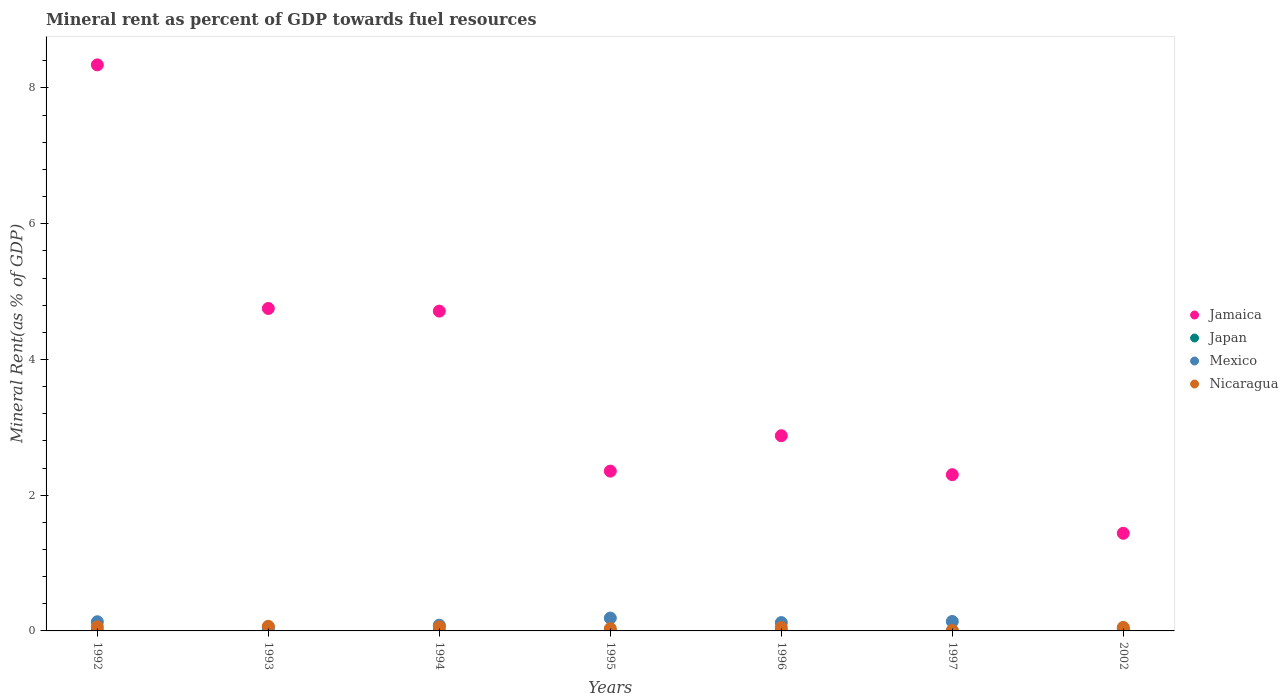How many different coloured dotlines are there?
Offer a very short reply. 4. Is the number of dotlines equal to the number of legend labels?
Ensure brevity in your answer.  Yes. What is the mineral rent in Jamaica in 1994?
Your response must be concise. 4.71. Across all years, what is the maximum mineral rent in Nicaragua?
Offer a terse response. 0.07. Across all years, what is the minimum mineral rent in Japan?
Provide a succinct answer. 4.86493891704915e-5. In which year was the mineral rent in Jamaica maximum?
Offer a very short reply. 1992. In which year was the mineral rent in Nicaragua minimum?
Your answer should be very brief. 1997. What is the total mineral rent in Nicaragua in the graph?
Your answer should be compact. 0.33. What is the difference between the mineral rent in Jamaica in 1995 and that in 1997?
Your answer should be very brief. 0.05. What is the difference between the mineral rent in Japan in 1993 and the mineral rent in Jamaica in 1992?
Offer a terse response. -8.34. What is the average mineral rent in Mexico per year?
Ensure brevity in your answer.  0.11. In the year 1992, what is the difference between the mineral rent in Nicaragua and mineral rent in Jamaica?
Your answer should be very brief. -8.28. In how many years, is the mineral rent in Mexico greater than 6.8 %?
Offer a terse response. 0. What is the ratio of the mineral rent in Mexico in 1995 to that in 1996?
Provide a succinct answer. 1.55. Is the mineral rent in Jamaica in 1992 less than that in 1993?
Make the answer very short. No. Is the difference between the mineral rent in Nicaragua in 1992 and 1997 greater than the difference between the mineral rent in Jamaica in 1992 and 1997?
Provide a succinct answer. No. What is the difference between the highest and the second highest mineral rent in Japan?
Give a very brief answer. 4.596113035733508e-5. What is the difference between the highest and the lowest mineral rent in Japan?
Keep it short and to the point. 0. Is it the case that in every year, the sum of the mineral rent in Japan and mineral rent in Mexico  is greater than the sum of mineral rent in Nicaragua and mineral rent in Jamaica?
Keep it short and to the point. No. Is it the case that in every year, the sum of the mineral rent in Mexico and mineral rent in Nicaragua  is greater than the mineral rent in Jamaica?
Offer a very short reply. No. How many years are there in the graph?
Your answer should be very brief. 7. What is the difference between two consecutive major ticks on the Y-axis?
Provide a short and direct response. 2. Where does the legend appear in the graph?
Offer a very short reply. Center right. How many legend labels are there?
Your response must be concise. 4. How are the legend labels stacked?
Offer a very short reply. Vertical. What is the title of the graph?
Your answer should be very brief. Mineral rent as percent of GDP towards fuel resources. Does "Bahamas" appear as one of the legend labels in the graph?
Provide a succinct answer. No. What is the label or title of the X-axis?
Your answer should be very brief. Years. What is the label or title of the Y-axis?
Keep it short and to the point. Mineral Rent(as % of GDP). What is the Mineral Rent(as % of GDP) in Jamaica in 1992?
Your answer should be very brief. 8.34. What is the Mineral Rent(as % of GDP) of Japan in 1992?
Your response must be concise. 0. What is the Mineral Rent(as % of GDP) of Mexico in 1992?
Offer a very short reply. 0.14. What is the Mineral Rent(as % of GDP) of Nicaragua in 1992?
Your response must be concise. 0.06. What is the Mineral Rent(as % of GDP) in Jamaica in 1993?
Make the answer very short. 4.75. What is the Mineral Rent(as % of GDP) of Japan in 1993?
Your answer should be very brief. 0. What is the Mineral Rent(as % of GDP) in Mexico in 1993?
Offer a terse response. 0.05. What is the Mineral Rent(as % of GDP) in Nicaragua in 1993?
Provide a short and direct response. 0.07. What is the Mineral Rent(as % of GDP) in Jamaica in 1994?
Ensure brevity in your answer.  4.71. What is the Mineral Rent(as % of GDP) in Japan in 1994?
Your answer should be compact. 0. What is the Mineral Rent(as % of GDP) in Mexico in 1994?
Your answer should be compact. 0.08. What is the Mineral Rent(as % of GDP) in Nicaragua in 1994?
Ensure brevity in your answer.  0.06. What is the Mineral Rent(as % of GDP) of Jamaica in 1995?
Give a very brief answer. 2.35. What is the Mineral Rent(as % of GDP) in Japan in 1995?
Provide a short and direct response. 0. What is the Mineral Rent(as % of GDP) of Mexico in 1995?
Offer a terse response. 0.19. What is the Mineral Rent(as % of GDP) of Nicaragua in 1995?
Provide a short and direct response. 0.03. What is the Mineral Rent(as % of GDP) of Jamaica in 1996?
Your response must be concise. 2.88. What is the Mineral Rent(as % of GDP) of Japan in 1996?
Your response must be concise. 0. What is the Mineral Rent(as % of GDP) in Mexico in 1996?
Ensure brevity in your answer.  0.12. What is the Mineral Rent(as % of GDP) in Nicaragua in 1996?
Provide a succinct answer. 0.05. What is the Mineral Rent(as % of GDP) in Jamaica in 1997?
Your response must be concise. 2.3. What is the Mineral Rent(as % of GDP) in Japan in 1997?
Provide a short and direct response. 4.86493891704915e-5. What is the Mineral Rent(as % of GDP) in Mexico in 1997?
Your answer should be compact. 0.14. What is the Mineral Rent(as % of GDP) of Nicaragua in 1997?
Provide a short and direct response. 0.01. What is the Mineral Rent(as % of GDP) of Jamaica in 2002?
Provide a short and direct response. 1.44. What is the Mineral Rent(as % of GDP) of Japan in 2002?
Ensure brevity in your answer.  0. What is the Mineral Rent(as % of GDP) in Mexico in 2002?
Give a very brief answer. 0.03. What is the Mineral Rent(as % of GDP) in Nicaragua in 2002?
Offer a terse response. 0.05. Across all years, what is the maximum Mineral Rent(as % of GDP) in Jamaica?
Offer a terse response. 8.34. Across all years, what is the maximum Mineral Rent(as % of GDP) of Japan?
Provide a short and direct response. 0. Across all years, what is the maximum Mineral Rent(as % of GDP) in Mexico?
Keep it short and to the point. 0.19. Across all years, what is the maximum Mineral Rent(as % of GDP) in Nicaragua?
Your answer should be very brief. 0.07. Across all years, what is the minimum Mineral Rent(as % of GDP) in Jamaica?
Offer a terse response. 1.44. Across all years, what is the minimum Mineral Rent(as % of GDP) in Japan?
Your response must be concise. 4.86493891704915e-5. Across all years, what is the minimum Mineral Rent(as % of GDP) of Mexico?
Make the answer very short. 0.03. Across all years, what is the minimum Mineral Rent(as % of GDP) in Nicaragua?
Your answer should be very brief. 0.01. What is the total Mineral Rent(as % of GDP) of Jamaica in the graph?
Make the answer very short. 26.77. What is the total Mineral Rent(as % of GDP) of Japan in the graph?
Make the answer very short. 0. What is the total Mineral Rent(as % of GDP) in Mexico in the graph?
Provide a succinct answer. 0.76. What is the total Mineral Rent(as % of GDP) in Nicaragua in the graph?
Your response must be concise. 0.33. What is the difference between the Mineral Rent(as % of GDP) of Jamaica in 1992 and that in 1993?
Your response must be concise. 3.59. What is the difference between the Mineral Rent(as % of GDP) of Japan in 1992 and that in 1993?
Give a very brief answer. 0. What is the difference between the Mineral Rent(as % of GDP) in Mexico in 1992 and that in 1993?
Your answer should be compact. 0.08. What is the difference between the Mineral Rent(as % of GDP) of Nicaragua in 1992 and that in 1993?
Provide a short and direct response. -0.01. What is the difference between the Mineral Rent(as % of GDP) in Jamaica in 1992 and that in 1994?
Ensure brevity in your answer.  3.63. What is the difference between the Mineral Rent(as % of GDP) of Japan in 1992 and that in 1994?
Your answer should be very brief. -0. What is the difference between the Mineral Rent(as % of GDP) in Mexico in 1992 and that in 1994?
Keep it short and to the point. 0.05. What is the difference between the Mineral Rent(as % of GDP) of Nicaragua in 1992 and that in 1994?
Keep it short and to the point. 0. What is the difference between the Mineral Rent(as % of GDP) of Jamaica in 1992 and that in 1995?
Ensure brevity in your answer.  5.99. What is the difference between the Mineral Rent(as % of GDP) in Mexico in 1992 and that in 1995?
Provide a short and direct response. -0.05. What is the difference between the Mineral Rent(as % of GDP) in Nicaragua in 1992 and that in 1995?
Provide a short and direct response. 0.03. What is the difference between the Mineral Rent(as % of GDP) in Jamaica in 1992 and that in 1996?
Give a very brief answer. 5.46. What is the difference between the Mineral Rent(as % of GDP) of Mexico in 1992 and that in 1996?
Keep it short and to the point. 0.01. What is the difference between the Mineral Rent(as % of GDP) of Nicaragua in 1992 and that in 1996?
Offer a terse response. 0.01. What is the difference between the Mineral Rent(as % of GDP) in Jamaica in 1992 and that in 1997?
Offer a terse response. 6.04. What is the difference between the Mineral Rent(as % of GDP) in Mexico in 1992 and that in 1997?
Keep it short and to the point. -0. What is the difference between the Mineral Rent(as % of GDP) of Nicaragua in 1992 and that in 1997?
Give a very brief answer. 0.05. What is the difference between the Mineral Rent(as % of GDP) of Jamaica in 1992 and that in 2002?
Your response must be concise. 6.9. What is the difference between the Mineral Rent(as % of GDP) in Japan in 1992 and that in 2002?
Ensure brevity in your answer.  0. What is the difference between the Mineral Rent(as % of GDP) of Mexico in 1992 and that in 2002?
Your answer should be very brief. 0.1. What is the difference between the Mineral Rent(as % of GDP) of Nicaragua in 1992 and that in 2002?
Keep it short and to the point. 0.01. What is the difference between the Mineral Rent(as % of GDP) in Jamaica in 1993 and that in 1994?
Your response must be concise. 0.04. What is the difference between the Mineral Rent(as % of GDP) of Japan in 1993 and that in 1994?
Make the answer very short. -0. What is the difference between the Mineral Rent(as % of GDP) in Mexico in 1993 and that in 1994?
Your response must be concise. -0.03. What is the difference between the Mineral Rent(as % of GDP) of Nicaragua in 1993 and that in 1994?
Your answer should be compact. 0.01. What is the difference between the Mineral Rent(as % of GDP) in Jamaica in 1993 and that in 1995?
Provide a short and direct response. 2.4. What is the difference between the Mineral Rent(as % of GDP) of Mexico in 1993 and that in 1995?
Your answer should be compact. -0.14. What is the difference between the Mineral Rent(as % of GDP) in Nicaragua in 1993 and that in 1995?
Provide a succinct answer. 0.03. What is the difference between the Mineral Rent(as % of GDP) of Jamaica in 1993 and that in 1996?
Offer a terse response. 1.88. What is the difference between the Mineral Rent(as % of GDP) in Japan in 1993 and that in 1996?
Make the answer very short. 0. What is the difference between the Mineral Rent(as % of GDP) of Mexico in 1993 and that in 1996?
Keep it short and to the point. -0.07. What is the difference between the Mineral Rent(as % of GDP) in Nicaragua in 1993 and that in 1996?
Offer a terse response. 0.02. What is the difference between the Mineral Rent(as % of GDP) in Jamaica in 1993 and that in 1997?
Your response must be concise. 2.45. What is the difference between the Mineral Rent(as % of GDP) in Japan in 1993 and that in 1997?
Your response must be concise. 0. What is the difference between the Mineral Rent(as % of GDP) in Mexico in 1993 and that in 1997?
Provide a succinct answer. -0.08. What is the difference between the Mineral Rent(as % of GDP) of Nicaragua in 1993 and that in 1997?
Your response must be concise. 0.06. What is the difference between the Mineral Rent(as % of GDP) in Jamaica in 1993 and that in 2002?
Offer a very short reply. 3.31. What is the difference between the Mineral Rent(as % of GDP) of Mexico in 1993 and that in 2002?
Offer a very short reply. 0.02. What is the difference between the Mineral Rent(as % of GDP) of Nicaragua in 1993 and that in 2002?
Provide a short and direct response. 0.02. What is the difference between the Mineral Rent(as % of GDP) in Jamaica in 1994 and that in 1995?
Provide a succinct answer. 2.36. What is the difference between the Mineral Rent(as % of GDP) of Japan in 1994 and that in 1995?
Your response must be concise. 0. What is the difference between the Mineral Rent(as % of GDP) in Mexico in 1994 and that in 1995?
Make the answer very short. -0.11. What is the difference between the Mineral Rent(as % of GDP) of Nicaragua in 1994 and that in 1995?
Give a very brief answer. 0.02. What is the difference between the Mineral Rent(as % of GDP) in Jamaica in 1994 and that in 1996?
Provide a succinct answer. 1.84. What is the difference between the Mineral Rent(as % of GDP) in Japan in 1994 and that in 1996?
Make the answer very short. 0. What is the difference between the Mineral Rent(as % of GDP) of Mexico in 1994 and that in 1996?
Your answer should be compact. -0.04. What is the difference between the Mineral Rent(as % of GDP) in Nicaragua in 1994 and that in 1996?
Provide a succinct answer. 0.01. What is the difference between the Mineral Rent(as % of GDP) of Jamaica in 1994 and that in 1997?
Keep it short and to the point. 2.41. What is the difference between the Mineral Rent(as % of GDP) of Mexico in 1994 and that in 1997?
Provide a succinct answer. -0.06. What is the difference between the Mineral Rent(as % of GDP) in Nicaragua in 1994 and that in 1997?
Provide a short and direct response. 0.05. What is the difference between the Mineral Rent(as % of GDP) of Jamaica in 1994 and that in 2002?
Make the answer very short. 3.27. What is the difference between the Mineral Rent(as % of GDP) in Japan in 1994 and that in 2002?
Offer a terse response. 0. What is the difference between the Mineral Rent(as % of GDP) of Mexico in 1994 and that in 2002?
Provide a succinct answer. 0.05. What is the difference between the Mineral Rent(as % of GDP) in Nicaragua in 1994 and that in 2002?
Provide a short and direct response. 0.01. What is the difference between the Mineral Rent(as % of GDP) of Jamaica in 1995 and that in 1996?
Offer a terse response. -0.52. What is the difference between the Mineral Rent(as % of GDP) in Japan in 1995 and that in 1996?
Make the answer very short. -0. What is the difference between the Mineral Rent(as % of GDP) of Mexico in 1995 and that in 1996?
Give a very brief answer. 0.07. What is the difference between the Mineral Rent(as % of GDP) of Nicaragua in 1995 and that in 1996?
Your answer should be very brief. -0.01. What is the difference between the Mineral Rent(as % of GDP) in Jamaica in 1995 and that in 1997?
Your answer should be compact. 0.05. What is the difference between the Mineral Rent(as % of GDP) of Japan in 1995 and that in 1997?
Offer a terse response. 0. What is the difference between the Mineral Rent(as % of GDP) of Mexico in 1995 and that in 1997?
Give a very brief answer. 0.05. What is the difference between the Mineral Rent(as % of GDP) in Nicaragua in 1995 and that in 1997?
Make the answer very short. 0.03. What is the difference between the Mineral Rent(as % of GDP) in Jamaica in 1995 and that in 2002?
Provide a succinct answer. 0.92. What is the difference between the Mineral Rent(as % of GDP) in Mexico in 1995 and that in 2002?
Your response must be concise. 0.16. What is the difference between the Mineral Rent(as % of GDP) of Nicaragua in 1995 and that in 2002?
Make the answer very short. -0.02. What is the difference between the Mineral Rent(as % of GDP) in Jamaica in 1996 and that in 1997?
Your answer should be very brief. 0.57. What is the difference between the Mineral Rent(as % of GDP) in Mexico in 1996 and that in 1997?
Ensure brevity in your answer.  -0.02. What is the difference between the Mineral Rent(as % of GDP) of Nicaragua in 1996 and that in 1997?
Provide a short and direct response. 0.04. What is the difference between the Mineral Rent(as % of GDP) in Jamaica in 1996 and that in 2002?
Offer a terse response. 1.44. What is the difference between the Mineral Rent(as % of GDP) in Mexico in 1996 and that in 2002?
Give a very brief answer. 0.09. What is the difference between the Mineral Rent(as % of GDP) in Nicaragua in 1996 and that in 2002?
Your answer should be very brief. -0. What is the difference between the Mineral Rent(as % of GDP) of Jamaica in 1997 and that in 2002?
Ensure brevity in your answer.  0.86. What is the difference between the Mineral Rent(as % of GDP) in Japan in 1997 and that in 2002?
Your response must be concise. -0. What is the difference between the Mineral Rent(as % of GDP) of Mexico in 1997 and that in 2002?
Your answer should be very brief. 0.11. What is the difference between the Mineral Rent(as % of GDP) in Nicaragua in 1997 and that in 2002?
Your answer should be very brief. -0.04. What is the difference between the Mineral Rent(as % of GDP) in Jamaica in 1992 and the Mineral Rent(as % of GDP) in Japan in 1993?
Keep it short and to the point. 8.34. What is the difference between the Mineral Rent(as % of GDP) of Jamaica in 1992 and the Mineral Rent(as % of GDP) of Mexico in 1993?
Ensure brevity in your answer.  8.29. What is the difference between the Mineral Rent(as % of GDP) of Jamaica in 1992 and the Mineral Rent(as % of GDP) of Nicaragua in 1993?
Your answer should be very brief. 8.27. What is the difference between the Mineral Rent(as % of GDP) of Japan in 1992 and the Mineral Rent(as % of GDP) of Mexico in 1993?
Make the answer very short. -0.05. What is the difference between the Mineral Rent(as % of GDP) of Japan in 1992 and the Mineral Rent(as % of GDP) of Nicaragua in 1993?
Keep it short and to the point. -0.07. What is the difference between the Mineral Rent(as % of GDP) of Mexico in 1992 and the Mineral Rent(as % of GDP) of Nicaragua in 1993?
Provide a short and direct response. 0.07. What is the difference between the Mineral Rent(as % of GDP) of Jamaica in 1992 and the Mineral Rent(as % of GDP) of Japan in 1994?
Provide a succinct answer. 8.34. What is the difference between the Mineral Rent(as % of GDP) in Jamaica in 1992 and the Mineral Rent(as % of GDP) in Mexico in 1994?
Your answer should be compact. 8.26. What is the difference between the Mineral Rent(as % of GDP) in Jamaica in 1992 and the Mineral Rent(as % of GDP) in Nicaragua in 1994?
Ensure brevity in your answer.  8.28. What is the difference between the Mineral Rent(as % of GDP) of Japan in 1992 and the Mineral Rent(as % of GDP) of Mexico in 1994?
Offer a terse response. -0.08. What is the difference between the Mineral Rent(as % of GDP) in Japan in 1992 and the Mineral Rent(as % of GDP) in Nicaragua in 1994?
Offer a very short reply. -0.06. What is the difference between the Mineral Rent(as % of GDP) of Mexico in 1992 and the Mineral Rent(as % of GDP) of Nicaragua in 1994?
Your response must be concise. 0.08. What is the difference between the Mineral Rent(as % of GDP) of Jamaica in 1992 and the Mineral Rent(as % of GDP) of Japan in 1995?
Your response must be concise. 8.34. What is the difference between the Mineral Rent(as % of GDP) of Jamaica in 1992 and the Mineral Rent(as % of GDP) of Mexico in 1995?
Your response must be concise. 8.15. What is the difference between the Mineral Rent(as % of GDP) in Jamaica in 1992 and the Mineral Rent(as % of GDP) in Nicaragua in 1995?
Offer a terse response. 8.31. What is the difference between the Mineral Rent(as % of GDP) in Japan in 1992 and the Mineral Rent(as % of GDP) in Mexico in 1995?
Your response must be concise. -0.19. What is the difference between the Mineral Rent(as % of GDP) of Japan in 1992 and the Mineral Rent(as % of GDP) of Nicaragua in 1995?
Provide a short and direct response. -0.03. What is the difference between the Mineral Rent(as % of GDP) in Mexico in 1992 and the Mineral Rent(as % of GDP) in Nicaragua in 1995?
Provide a short and direct response. 0.1. What is the difference between the Mineral Rent(as % of GDP) of Jamaica in 1992 and the Mineral Rent(as % of GDP) of Japan in 1996?
Keep it short and to the point. 8.34. What is the difference between the Mineral Rent(as % of GDP) of Jamaica in 1992 and the Mineral Rent(as % of GDP) of Mexico in 1996?
Provide a short and direct response. 8.22. What is the difference between the Mineral Rent(as % of GDP) of Jamaica in 1992 and the Mineral Rent(as % of GDP) of Nicaragua in 1996?
Offer a very short reply. 8.29. What is the difference between the Mineral Rent(as % of GDP) in Japan in 1992 and the Mineral Rent(as % of GDP) in Mexico in 1996?
Offer a very short reply. -0.12. What is the difference between the Mineral Rent(as % of GDP) in Japan in 1992 and the Mineral Rent(as % of GDP) in Nicaragua in 1996?
Your answer should be compact. -0.05. What is the difference between the Mineral Rent(as % of GDP) in Mexico in 1992 and the Mineral Rent(as % of GDP) in Nicaragua in 1996?
Provide a short and direct response. 0.09. What is the difference between the Mineral Rent(as % of GDP) of Jamaica in 1992 and the Mineral Rent(as % of GDP) of Japan in 1997?
Offer a very short reply. 8.34. What is the difference between the Mineral Rent(as % of GDP) of Jamaica in 1992 and the Mineral Rent(as % of GDP) of Mexico in 1997?
Offer a very short reply. 8.2. What is the difference between the Mineral Rent(as % of GDP) in Jamaica in 1992 and the Mineral Rent(as % of GDP) in Nicaragua in 1997?
Provide a succinct answer. 8.33. What is the difference between the Mineral Rent(as % of GDP) of Japan in 1992 and the Mineral Rent(as % of GDP) of Mexico in 1997?
Your answer should be compact. -0.14. What is the difference between the Mineral Rent(as % of GDP) in Japan in 1992 and the Mineral Rent(as % of GDP) in Nicaragua in 1997?
Offer a terse response. -0.01. What is the difference between the Mineral Rent(as % of GDP) in Mexico in 1992 and the Mineral Rent(as % of GDP) in Nicaragua in 1997?
Provide a short and direct response. 0.13. What is the difference between the Mineral Rent(as % of GDP) of Jamaica in 1992 and the Mineral Rent(as % of GDP) of Japan in 2002?
Offer a very short reply. 8.34. What is the difference between the Mineral Rent(as % of GDP) in Jamaica in 1992 and the Mineral Rent(as % of GDP) in Mexico in 2002?
Provide a succinct answer. 8.31. What is the difference between the Mineral Rent(as % of GDP) of Jamaica in 1992 and the Mineral Rent(as % of GDP) of Nicaragua in 2002?
Offer a terse response. 8.29. What is the difference between the Mineral Rent(as % of GDP) in Japan in 1992 and the Mineral Rent(as % of GDP) in Mexico in 2002?
Give a very brief answer. -0.03. What is the difference between the Mineral Rent(as % of GDP) in Japan in 1992 and the Mineral Rent(as % of GDP) in Nicaragua in 2002?
Provide a short and direct response. -0.05. What is the difference between the Mineral Rent(as % of GDP) of Mexico in 1992 and the Mineral Rent(as % of GDP) of Nicaragua in 2002?
Keep it short and to the point. 0.08. What is the difference between the Mineral Rent(as % of GDP) in Jamaica in 1993 and the Mineral Rent(as % of GDP) in Japan in 1994?
Your response must be concise. 4.75. What is the difference between the Mineral Rent(as % of GDP) in Jamaica in 1993 and the Mineral Rent(as % of GDP) in Mexico in 1994?
Ensure brevity in your answer.  4.67. What is the difference between the Mineral Rent(as % of GDP) in Jamaica in 1993 and the Mineral Rent(as % of GDP) in Nicaragua in 1994?
Provide a short and direct response. 4.69. What is the difference between the Mineral Rent(as % of GDP) of Japan in 1993 and the Mineral Rent(as % of GDP) of Mexico in 1994?
Offer a very short reply. -0.08. What is the difference between the Mineral Rent(as % of GDP) of Japan in 1993 and the Mineral Rent(as % of GDP) of Nicaragua in 1994?
Make the answer very short. -0.06. What is the difference between the Mineral Rent(as % of GDP) of Mexico in 1993 and the Mineral Rent(as % of GDP) of Nicaragua in 1994?
Your answer should be very brief. -0.01. What is the difference between the Mineral Rent(as % of GDP) in Jamaica in 1993 and the Mineral Rent(as % of GDP) in Japan in 1995?
Provide a succinct answer. 4.75. What is the difference between the Mineral Rent(as % of GDP) in Jamaica in 1993 and the Mineral Rent(as % of GDP) in Mexico in 1995?
Your answer should be compact. 4.56. What is the difference between the Mineral Rent(as % of GDP) of Jamaica in 1993 and the Mineral Rent(as % of GDP) of Nicaragua in 1995?
Offer a very short reply. 4.72. What is the difference between the Mineral Rent(as % of GDP) of Japan in 1993 and the Mineral Rent(as % of GDP) of Mexico in 1995?
Ensure brevity in your answer.  -0.19. What is the difference between the Mineral Rent(as % of GDP) in Japan in 1993 and the Mineral Rent(as % of GDP) in Nicaragua in 1995?
Make the answer very short. -0.03. What is the difference between the Mineral Rent(as % of GDP) of Mexico in 1993 and the Mineral Rent(as % of GDP) of Nicaragua in 1995?
Provide a short and direct response. 0.02. What is the difference between the Mineral Rent(as % of GDP) of Jamaica in 1993 and the Mineral Rent(as % of GDP) of Japan in 1996?
Offer a terse response. 4.75. What is the difference between the Mineral Rent(as % of GDP) in Jamaica in 1993 and the Mineral Rent(as % of GDP) in Mexico in 1996?
Provide a succinct answer. 4.63. What is the difference between the Mineral Rent(as % of GDP) of Jamaica in 1993 and the Mineral Rent(as % of GDP) of Nicaragua in 1996?
Give a very brief answer. 4.7. What is the difference between the Mineral Rent(as % of GDP) of Japan in 1993 and the Mineral Rent(as % of GDP) of Mexico in 1996?
Make the answer very short. -0.12. What is the difference between the Mineral Rent(as % of GDP) of Japan in 1993 and the Mineral Rent(as % of GDP) of Nicaragua in 1996?
Give a very brief answer. -0.05. What is the difference between the Mineral Rent(as % of GDP) of Mexico in 1993 and the Mineral Rent(as % of GDP) of Nicaragua in 1996?
Your response must be concise. 0. What is the difference between the Mineral Rent(as % of GDP) of Jamaica in 1993 and the Mineral Rent(as % of GDP) of Japan in 1997?
Keep it short and to the point. 4.75. What is the difference between the Mineral Rent(as % of GDP) in Jamaica in 1993 and the Mineral Rent(as % of GDP) in Mexico in 1997?
Offer a very short reply. 4.61. What is the difference between the Mineral Rent(as % of GDP) in Jamaica in 1993 and the Mineral Rent(as % of GDP) in Nicaragua in 1997?
Your answer should be compact. 4.74. What is the difference between the Mineral Rent(as % of GDP) of Japan in 1993 and the Mineral Rent(as % of GDP) of Mexico in 1997?
Make the answer very short. -0.14. What is the difference between the Mineral Rent(as % of GDP) of Japan in 1993 and the Mineral Rent(as % of GDP) of Nicaragua in 1997?
Provide a succinct answer. -0.01. What is the difference between the Mineral Rent(as % of GDP) of Mexico in 1993 and the Mineral Rent(as % of GDP) of Nicaragua in 1997?
Your response must be concise. 0.05. What is the difference between the Mineral Rent(as % of GDP) in Jamaica in 1993 and the Mineral Rent(as % of GDP) in Japan in 2002?
Give a very brief answer. 4.75. What is the difference between the Mineral Rent(as % of GDP) of Jamaica in 1993 and the Mineral Rent(as % of GDP) of Mexico in 2002?
Offer a very short reply. 4.72. What is the difference between the Mineral Rent(as % of GDP) of Jamaica in 1993 and the Mineral Rent(as % of GDP) of Nicaragua in 2002?
Provide a succinct answer. 4.7. What is the difference between the Mineral Rent(as % of GDP) in Japan in 1993 and the Mineral Rent(as % of GDP) in Mexico in 2002?
Your answer should be very brief. -0.03. What is the difference between the Mineral Rent(as % of GDP) in Japan in 1993 and the Mineral Rent(as % of GDP) in Nicaragua in 2002?
Provide a succinct answer. -0.05. What is the difference between the Mineral Rent(as % of GDP) of Mexico in 1993 and the Mineral Rent(as % of GDP) of Nicaragua in 2002?
Your response must be concise. 0. What is the difference between the Mineral Rent(as % of GDP) of Jamaica in 1994 and the Mineral Rent(as % of GDP) of Japan in 1995?
Your answer should be very brief. 4.71. What is the difference between the Mineral Rent(as % of GDP) in Jamaica in 1994 and the Mineral Rent(as % of GDP) in Mexico in 1995?
Provide a short and direct response. 4.52. What is the difference between the Mineral Rent(as % of GDP) of Jamaica in 1994 and the Mineral Rent(as % of GDP) of Nicaragua in 1995?
Offer a terse response. 4.68. What is the difference between the Mineral Rent(as % of GDP) of Japan in 1994 and the Mineral Rent(as % of GDP) of Mexico in 1995?
Keep it short and to the point. -0.19. What is the difference between the Mineral Rent(as % of GDP) in Japan in 1994 and the Mineral Rent(as % of GDP) in Nicaragua in 1995?
Provide a succinct answer. -0.03. What is the difference between the Mineral Rent(as % of GDP) in Mexico in 1994 and the Mineral Rent(as % of GDP) in Nicaragua in 1995?
Your response must be concise. 0.05. What is the difference between the Mineral Rent(as % of GDP) of Jamaica in 1994 and the Mineral Rent(as % of GDP) of Japan in 1996?
Provide a succinct answer. 4.71. What is the difference between the Mineral Rent(as % of GDP) of Jamaica in 1994 and the Mineral Rent(as % of GDP) of Mexico in 1996?
Your response must be concise. 4.59. What is the difference between the Mineral Rent(as % of GDP) in Jamaica in 1994 and the Mineral Rent(as % of GDP) in Nicaragua in 1996?
Provide a succinct answer. 4.66. What is the difference between the Mineral Rent(as % of GDP) in Japan in 1994 and the Mineral Rent(as % of GDP) in Mexico in 1996?
Provide a succinct answer. -0.12. What is the difference between the Mineral Rent(as % of GDP) in Japan in 1994 and the Mineral Rent(as % of GDP) in Nicaragua in 1996?
Provide a succinct answer. -0.05. What is the difference between the Mineral Rent(as % of GDP) in Mexico in 1994 and the Mineral Rent(as % of GDP) in Nicaragua in 1996?
Your response must be concise. 0.03. What is the difference between the Mineral Rent(as % of GDP) in Jamaica in 1994 and the Mineral Rent(as % of GDP) in Japan in 1997?
Keep it short and to the point. 4.71. What is the difference between the Mineral Rent(as % of GDP) in Jamaica in 1994 and the Mineral Rent(as % of GDP) in Mexico in 1997?
Offer a terse response. 4.57. What is the difference between the Mineral Rent(as % of GDP) of Jamaica in 1994 and the Mineral Rent(as % of GDP) of Nicaragua in 1997?
Your response must be concise. 4.7. What is the difference between the Mineral Rent(as % of GDP) in Japan in 1994 and the Mineral Rent(as % of GDP) in Mexico in 1997?
Keep it short and to the point. -0.14. What is the difference between the Mineral Rent(as % of GDP) of Japan in 1994 and the Mineral Rent(as % of GDP) of Nicaragua in 1997?
Your answer should be compact. -0.01. What is the difference between the Mineral Rent(as % of GDP) of Mexico in 1994 and the Mineral Rent(as % of GDP) of Nicaragua in 1997?
Your response must be concise. 0.08. What is the difference between the Mineral Rent(as % of GDP) in Jamaica in 1994 and the Mineral Rent(as % of GDP) in Japan in 2002?
Your answer should be compact. 4.71. What is the difference between the Mineral Rent(as % of GDP) in Jamaica in 1994 and the Mineral Rent(as % of GDP) in Mexico in 2002?
Keep it short and to the point. 4.68. What is the difference between the Mineral Rent(as % of GDP) in Jamaica in 1994 and the Mineral Rent(as % of GDP) in Nicaragua in 2002?
Offer a very short reply. 4.66. What is the difference between the Mineral Rent(as % of GDP) of Japan in 1994 and the Mineral Rent(as % of GDP) of Mexico in 2002?
Provide a short and direct response. -0.03. What is the difference between the Mineral Rent(as % of GDP) of Japan in 1994 and the Mineral Rent(as % of GDP) of Nicaragua in 2002?
Your response must be concise. -0.05. What is the difference between the Mineral Rent(as % of GDP) in Mexico in 1994 and the Mineral Rent(as % of GDP) in Nicaragua in 2002?
Ensure brevity in your answer.  0.03. What is the difference between the Mineral Rent(as % of GDP) of Jamaica in 1995 and the Mineral Rent(as % of GDP) of Japan in 1996?
Your response must be concise. 2.35. What is the difference between the Mineral Rent(as % of GDP) in Jamaica in 1995 and the Mineral Rent(as % of GDP) in Mexico in 1996?
Give a very brief answer. 2.23. What is the difference between the Mineral Rent(as % of GDP) in Jamaica in 1995 and the Mineral Rent(as % of GDP) in Nicaragua in 1996?
Ensure brevity in your answer.  2.31. What is the difference between the Mineral Rent(as % of GDP) in Japan in 1995 and the Mineral Rent(as % of GDP) in Mexico in 1996?
Your answer should be very brief. -0.12. What is the difference between the Mineral Rent(as % of GDP) in Japan in 1995 and the Mineral Rent(as % of GDP) in Nicaragua in 1996?
Offer a very short reply. -0.05. What is the difference between the Mineral Rent(as % of GDP) in Mexico in 1995 and the Mineral Rent(as % of GDP) in Nicaragua in 1996?
Your answer should be very brief. 0.14. What is the difference between the Mineral Rent(as % of GDP) of Jamaica in 1995 and the Mineral Rent(as % of GDP) of Japan in 1997?
Give a very brief answer. 2.35. What is the difference between the Mineral Rent(as % of GDP) in Jamaica in 1995 and the Mineral Rent(as % of GDP) in Mexico in 1997?
Your answer should be compact. 2.22. What is the difference between the Mineral Rent(as % of GDP) of Jamaica in 1995 and the Mineral Rent(as % of GDP) of Nicaragua in 1997?
Your answer should be compact. 2.35. What is the difference between the Mineral Rent(as % of GDP) of Japan in 1995 and the Mineral Rent(as % of GDP) of Mexico in 1997?
Provide a succinct answer. -0.14. What is the difference between the Mineral Rent(as % of GDP) in Japan in 1995 and the Mineral Rent(as % of GDP) in Nicaragua in 1997?
Keep it short and to the point. -0.01. What is the difference between the Mineral Rent(as % of GDP) of Mexico in 1995 and the Mineral Rent(as % of GDP) of Nicaragua in 1997?
Give a very brief answer. 0.18. What is the difference between the Mineral Rent(as % of GDP) of Jamaica in 1995 and the Mineral Rent(as % of GDP) of Japan in 2002?
Offer a terse response. 2.35. What is the difference between the Mineral Rent(as % of GDP) of Jamaica in 1995 and the Mineral Rent(as % of GDP) of Mexico in 2002?
Give a very brief answer. 2.32. What is the difference between the Mineral Rent(as % of GDP) in Jamaica in 1995 and the Mineral Rent(as % of GDP) in Nicaragua in 2002?
Ensure brevity in your answer.  2.3. What is the difference between the Mineral Rent(as % of GDP) of Japan in 1995 and the Mineral Rent(as % of GDP) of Mexico in 2002?
Provide a short and direct response. -0.03. What is the difference between the Mineral Rent(as % of GDP) of Japan in 1995 and the Mineral Rent(as % of GDP) of Nicaragua in 2002?
Make the answer very short. -0.05. What is the difference between the Mineral Rent(as % of GDP) of Mexico in 1995 and the Mineral Rent(as % of GDP) of Nicaragua in 2002?
Give a very brief answer. 0.14. What is the difference between the Mineral Rent(as % of GDP) in Jamaica in 1996 and the Mineral Rent(as % of GDP) in Japan in 1997?
Make the answer very short. 2.88. What is the difference between the Mineral Rent(as % of GDP) of Jamaica in 1996 and the Mineral Rent(as % of GDP) of Mexico in 1997?
Give a very brief answer. 2.74. What is the difference between the Mineral Rent(as % of GDP) in Jamaica in 1996 and the Mineral Rent(as % of GDP) in Nicaragua in 1997?
Ensure brevity in your answer.  2.87. What is the difference between the Mineral Rent(as % of GDP) of Japan in 1996 and the Mineral Rent(as % of GDP) of Mexico in 1997?
Offer a very short reply. -0.14. What is the difference between the Mineral Rent(as % of GDP) in Japan in 1996 and the Mineral Rent(as % of GDP) in Nicaragua in 1997?
Offer a terse response. -0.01. What is the difference between the Mineral Rent(as % of GDP) of Mexico in 1996 and the Mineral Rent(as % of GDP) of Nicaragua in 1997?
Provide a succinct answer. 0.12. What is the difference between the Mineral Rent(as % of GDP) in Jamaica in 1996 and the Mineral Rent(as % of GDP) in Japan in 2002?
Offer a terse response. 2.88. What is the difference between the Mineral Rent(as % of GDP) of Jamaica in 1996 and the Mineral Rent(as % of GDP) of Mexico in 2002?
Give a very brief answer. 2.84. What is the difference between the Mineral Rent(as % of GDP) in Jamaica in 1996 and the Mineral Rent(as % of GDP) in Nicaragua in 2002?
Offer a very short reply. 2.82. What is the difference between the Mineral Rent(as % of GDP) of Japan in 1996 and the Mineral Rent(as % of GDP) of Mexico in 2002?
Your answer should be very brief. -0.03. What is the difference between the Mineral Rent(as % of GDP) in Japan in 1996 and the Mineral Rent(as % of GDP) in Nicaragua in 2002?
Keep it short and to the point. -0.05. What is the difference between the Mineral Rent(as % of GDP) in Mexico in 1996 and the Mineral Rent(as % of GDP) in Nicaragua in 2002?
Keep it short and to the point. 0.07. What is the difference between the Mineral Rent(as % of GDP) of Jamaica in 1997 and the Mineral Rent(as % of GDP) of Japan in 2002?
Your answer should be very brief. 2.3. What is the difference between the Mineral Rent(as % of GDP) in Jamaica in 1997 and the Mineral Rent(as % of GDP) in Mexico in 2002?
Offer a terse response. 2.27. What is the difference between the Mineral Rent(as % of GDP) of Jamaica in 1997 and the Mineral Rent(as % of GDP) of Nicaragua in 2002?
Give a very brief answer. 2.25. What is the difference between the Mineral Rent(as % of GDP) of Japan in 1997 and the Mineral Rent(as % of GDP) of Mexico in 2002?
Keep it short and to the point. -0.03. What is the difference between the Mineral Rent(as % of GDP) in Japan in 1997 and the Mineral Rent(as % of GDP) in Nicaragua in 2002?
Your answer should be very brief. -0.05. What is the difference between the Mineral Rent(as % of GDP) of Mexico in 1997 and the Mineral Rent(as % of GDP) of Nicaragua in 2002?
Your answer should be very brief. 0.09. What is the average Mineral Rent(as % of GDP) of Jamaica per year?
Your response must be concise. 3.83. What is the average Mineral Rent(as % of GDP) in Japan per year?
Your response must be concise. 0. What is the average Mineral Rent(as % of GDP) in Mexico per year?
Provide a succinct answer. 0.11. What is the average Mineral Rent(as % of GDP) of Nicaragua per year?
Provide a succinct answer. 0.05. In the year 1992, what is the difference between the Mineral Rent(as % of GDP) in Jamaica and Mineral Rent(as % of GDP) in Japan?
Ensure brevity in your answer.  8.34. In the year 1992, what is the difference between the Mineral Rent(as % of GDP) of Jamaica and Mineral Rent(as % of GDP) of Mexico?
Make the answer very short. 8.21. In the year 1992, what is the difference between the Mineral Rent(as % of GDP) of Jamaica and Mineral Rent(as % of GDP) of Nicaragua?
Make the answer very short. 8.28. In the year 1992, what is the difference between the Mineral Rent(as % of GDP) of Japan and Mineral Rent(as % of GDP) of Mexico?
Your response must be concise. -0.13. In the year 1992, what is the difference between the Mineral Rent(as % of GDP) of Japan and Mineral Rent(as % of GDP) of Nicaragua?
Give a very brief answer. -0.06. In the year 1992, what is the difference between the Mineral Rent(as % of GDP) in Mexico and Mineral Rent(as % of GDP) in Nicaragua?
Give a very brief answer. 0.07. In the year 1993, what is the difference between the Mineral Rent(as % of GDP) in Jamaica and Mineral Rent(as % of GDP) in Japan?
Make the answer very short. 4.75. In the year 1993, what is the difference between the Mineral Rent(as % of GDP) of Jamaica and Mineral Rent(as % of GDP) of Mexico?
Keep it short and to the point. 4.7. In the year 1993, what is the difference between the Mineral Rent(as % of GDP) of Jamaica and Mineral Rent(as % of GDP) of Nicaragua?
Offer a very short reply. 4.68. In the year 1993, what is the difference between the Mineral Rent(as % of GDP) of Japan and Mineral Rent(as % of GDP) of Mexico?
Provide a succinct answer. -0.05. In the year 1993, what is the difference between the Mineral Rent(as % of GDP) of Japan and Mineral Rent(as % of GDP) of Nicaragua?
Keep it short and to the point. -0.07. In the year 1993, what is the difference between the Mineral Rent(as % of GDP) in Mexico and Mineral Rent(as % of GDP) in Nicaragua?
Your answer should be very brief. -0.01. In the year 1994, what is the difference between the Mineral Rent(as % of GDP) of Jamaica and Mineral Rent(as % of GDP) of Japan?
Keep it short and to the point. 4.71. In the year 1994, what is the difference between the Mineral Rent(as % of GDP) of Jamaica and Mineral Rent(as % of GDP) of Mexico?
Provide a short and direct response. 4.63. In the year 1994, what is the difference between the Mineral Rent(as % of GDP) of Jamaica and Mineral Rent(as % of GDP) of Nicaragua?
Provide a succinct answer. 4.65. In the year 1994, what is the difference between the Mineral Rent(as % of GDP) in Japan and Mineral Rent(as % of GDP) in Mexico?
Make the answer very short. -0.08. In the year 1994, what is the difference between the Mineral Rent(as % of GDP) in Japan and Mineral Rent(as % of GDP) in Nicaragua?
Ensure brevity in your answer.  -0.06. In the year 1994, what is the difference between the Mineral Rent(as % of GDP) of Mexico and Mineral Rent(as % of GDP) of Nicaragua?
Your answer should be compact. 0.02. In the year 1995, what is the difference between the Mineral Rent(as % of GDP) in Jamaica and Mineral Rent(as % of GDP) in Japan?
Your answer should be compact. 2.35. In the year 1995, what is the difference between the Mineral Rent(as % of GDP) of Jamaica and Mineral Rent(as % of GDP) of Mexico?
Provide a short and direct response. 2.16. In the year 1995, what is the difference between the Mineral Rent(as % of GDP) in Jamaica and Mineral Rent(as % of GDP) in Nicaragua?
Provide a succinct answer. 2.32. In the year 1995, what is the difference between the Mineral Rent(as % of GDP) of Japan and Mineral Rent(as % of GDP) of Mexico?
Give a very brief answer. -0.19. In the year 1995, what is the difference between the Mineral Rent(as % of GDP) of Japan and Mineral Rent(as % of GDP) of Nicaragua?
Provide a succinct answer. -0.03. In the year 1995, what is the difference between the Mineral Rent(as % of GDP) in Mexico and Mineral Rent(as % of GDP) in Nicaragua?
Provide a short and direct response. 0.15. In the year 1996, what is the difference between the Mineral Rent(as % of GDP) of Jamaica and Mineral Rent(as % of GDP) of Japan?
Make the answer very short. 2.88. In the year 1996, what is the difference between the Mineral Rent(as % of GDP) in Jamaica and Mineral Rent(as % of GDP) in Mexico?
Your response must be concise. 2.75. In the year 1996, what is the difference between the Mineral Rent(as % of GDP) in Jamaica and Mineral Rent(as % of GDP) in Nicaragua?
Keep it short and to the point. 2.83. In the year 1996, what is the difference between the Mineral Rent(as % of GDP) of Japan and Mineral Rent(as % of GDP) of Mexico?
Your answer should be very brief. -0.12. In the year 1996, what is the difference between the Mineral Rent(as % of GDP) of Japan and Mineral Rent(as % of GDP) of Nicaragua?
Give a very brief answer. -0.05. In the year 1996, what is the difference between the Mineral Rent(as % of GDP) in Mexico and Mineral Rent(as % of GDP) in Nicaragua?
Offer a terse response. 0.07. In the year 1997, what is the difference between the Mineral Rent(as % of GDP) in Jamaica and Mineral Rent(as % of GDP) in Japan?
Ensure brevity in your answer.  2.3. In the year 1997, what is the difference between the Mineral Rent(as % of GDP) of Jamaica and Mineral Rent(as % of GDP) of Mexico?
Your answer should be compact. 2.16. In the year 1997, what is the difference between the Mineral Rent(as % of GDP) in Jamaica and Mineral Rent(as % of GDP) in Nicaragua?
Keep it short and to the point. 2.29. In the year 1997, what is the difference between the Mineral Rent(as % of GDP) in Japan and Mineral Rent(as % of GDP) in Mexico?
Your answer should be compact. -0.14. In the year 1997, what is the difference between the Mineral Rent(as % of GDP) in Japan and Mineral Rent(as % of GDP) in Nicaragua?
Offer a very short reply. -0.01. In the year 1997, what is the difference between the Mineral Rent(as % of GDP) in Mexico and Mineral Rent(as % of GDP) in Nicaragua?
Provide a short and direct response. 0.13. In the year 2002, what is the difference between the Mineral Rent(as % of GDP) in Jamaica and Mineral Rent(as % of GDP) in Japan?
Offer a terse response. 1.44. In the year 2002, what is the difference between the Mineral Rent(as % of GDP) in Jamaica and Mineral Rent(as % of GDP) in Mexico?
Make the answer very short. 1.41. In the year 2002, what is the difference between the Mineral Rent(as % of GDP) in Jamaica and Mineral Rent(as % of GDP) in Nicaragua?
Your answer should be compact. 1.39. In the year 2002, what is the difference between the Mineral Rent(as % of GDP) of Japan and Mineral Rent(as % of GDP) of Mexico?
Offer a terse response. -0.03. In the year 2002, what is the difference between the Mineral Rent(as % of GDP) in Japan and Mineral Rent(as % of GDP) in Nicaragua?
Provide a succinct answer. -0.05. In the year 2002, what is the difference between the Mineral Rent(as % of GDP) in Mexico and Mineral Rent(as % of GDP) in Nicaragua?
Provide a short and direct response. -0.02. What is the ratio of the Mineral Rent(as % of GDP) of Jamaica in 1992 to that in 1993?
Make the answer very short. 1.76. What is the ratio of the Mineral Rent(as % of GDP) of Japan in 1992 to that in 1993?
Give a very brief answer. 1.47. What is the ratio of the Mineral Rent(as % of GDP) in Mexico in 1992 to that in 1993?
Keep it short and to the point. 2.48. What is the ratio of the Mineral Rent(as % of GDP) in Nicaragua in 1992 to that in 1993?
Your answer should be compact. 0.89. What is the ratio of the Mineral Rent(as % of GDP) in Jamaica in 1992 to that in 1994?
Your response must be concise. 1.77. What is the ratio of the Mineral Rent(as % of GDP) of Japan in 1992 to that in 1994?
Offer a very short reply. 0.91. What is the ratio of the Mineral Rent(as % of GDP) of Mexico in 1992 to that in 1994?
Ensure brevity in your answer.  1.6. What is the ratio of the Mineral Rent(as % of GDP) in Nicaragua in 1992 to that in 1994?
Your response must be concise. 1.01. What is the ratio of the Mineral Rent(as % of GDP) of Jamaica in 1992 to that in 1995?
Your answer should be very brief. 3.54. What is the ratio of the Mineral Rent(as % of GDP) in Japan in 1992 to that in 1995?
Make the answer very short. 1.9. What is the ratio of the Mineral Rent(as % of GDP) of Mexico in 1992 to that in 1995?
Make the answer very short. 0.71. What is the ratio of the Mineral Rent(as % of GDP) of Nicaragua in 1992 to that in 1995?
Offer a very short reply. 1.74. What is the ratio of the Mineral Rent(as % of GDP) of Japan in 1992 to that in 1996?
Your answer should be compact. 1.57. What is the ratio of the Mineral Rent(as % of GDP) of Mexico in 1992 to that in 1996?
Your answer should be very brief. 1.1. What is the ratio of the Mineral Rent(as % of GDP) in Nicaragua in 1992 to that in 1996?
Provide a succinct answer. 1.22. What is the ratio of the Mineral Rent(as % of GDP) of Jamaica in 1992 to that in 1997?
Provide a succinct answer. 3.62. What is the ratio of the Mineral Rent(as % of GDP) in Japan in 1992 to that in 1997?
Your response must be concise. 9.99. What is the ratio of the Mineral Rent(as % of GDP) of Mexico in 1992 to that in 1997?
Offer a terse response. 0.97. What is the ratio of the Mineral Rent(as % of GDP) in Nicaragua in 1992 to that in 1997?
Keep it short and to the point. 8.51. What is the ratio of the Mineral Rent(as % of GDP) in Jamaica in 1992 to that in 2002?
Provide a succinct answer. 5.8. What is the ratio of the Mineral Rent(as % of GDP) of Japan in 1992 to that in 2002?
Your answer should be very brief. 3.1. What is the ratio of the Mineral Rent(as % of GDP) of Mexico in 1992 to that in 2002?
Provide a succinct answer. 4.03. What is the ratio of the Mineral Rent(as % of GDP) of Nicaragua in 1992 to that in 2002?
Give a very brief answer. 1.16. What is the ratio of the Mineral Rent(as % of GDP) of Jamaica in 1993 to that in 1994?
Your response must be concise. 1.01. What is the ratio of the Mineral Rent(as % of GDP) of Japan in 1993 to that in 1994?
Your answer should be compact. 0.62. What is the ratio of the Mineral Rent(as % of GDP) of Mexico in 1993 to that in 1994?
Ensure brevity in your answer.  0.65. What is the ratio of the Mineral Rent(as % of GDP) in Nicaragua in 1993 to that in 1994?
Make the answer very short. 1.14. What is the ratio of the Mineral Rent(as % of GDP) in Jamaica in 1993 to that in 1995?
Your answer should be compact. 2.02. What is the ratio of the Mineral Rent(as % of GDP) in Japan in 1993 to that in 1995?
Ensure brevity in your answer.  1.3. What is the ratio of the Mineral Rent(as % of GDP) in Mexico in 1993 to that in 1995?
Offer a terse response. 0.29. What is the ratio of the Mineral Rent(as % of GDP) in Nicaragua in 1993 to that in 1995?
Provide a short and direct response. 1.96. What is the ratio of the Mineral Rent(as % of GDP) of Jamaica in 1993 to that in 1996?
Ensure brevity in your answer.  1.65. What is the ratio of the Mineral Rent(as % of GDP) in Japan in 1993 to that in 1996?
Your response must be concise. 1.07. What is the ratio of the Mineral Rent(as % of GDP) of Mexico in 1993 to that in 1996?
Give a very brief answer. 0.44. What is the ratio of the Mineral Rent(as % of GDP) in Nicaragua in 1993 to that in 1996?
Provide a succinct answer. 1.37. What is the ratio of the Mineral Rent(as % of GDP) in Jamaica in 1993 to that in 1997?
Give a very brief answer. 2.06. What is the ratio of the Mineral Rent(as % of GDP) in Japan in 1993 to that in 1997?
Offer a very short reply. 6.81. What is the ratio of the Mineral Rent(as % of GDP) in Mexico in 1993 to that in 1997?
Make the answer very short. 0.39. What is the ratio of the Mineral Rent(as % of GDP) of Nicaragua in 1993 to that in 1997?
Your answer should be compact. 9.59. What is the ratio of the Mineral Rent(as % of GDP) in Jamaica in 1993 to that in 2002?
Make the answer very short. 3.3. What is the ratio of the Mineral Rent(as % of GDP) of Japan in 1993 to that in 2002?
Make the answer very short. 2.11. What is the ratio of the Mineral Rent(as % of GDP) in Mexico in 1993 to that in 2002?
Your answer should be compact. 1.62. What is the ratio of the Mineral Rent(as % of GDP) of Nicaragua in 1993 to that in 2002?
Make the answer very short. 1.31. What is the ratio of the Mineral Rent(as % of GDP) of Jamaica in 1994 to that in 1995?
Keep it short and to the point. 2. What is the ratio of the Mineral Rent(as % of GDP) in Japan in 1994 to that in 1995?
Your answer should be compact. 2.08. What is the ratio of the Mineral Rent(as % of GDP) in Mexico in 1994 to that in 1995?
Your answer should be compact. 0.44. What is the ratio of the Mineral Rent(as % of GDP) of Nicaragua in 1994 to that in 1995?
Offer a very short reply. 1.71. What is the ratio of the Mineral Rent(as % of GDP) in Jamaica in 1994 to that in 1996?
Offer a very short reply. 1.64. What is the ratio of the Mineral Rent(as % of GDP) in Japan in 1994 to that in 1996?
Provide a succinct answer. 1.72. What is the ratio of the Mineral Rent(as % of GDP) in Mexico in 1994 to that in 1996?
Give a very brief answer. 0.69. What is the ratio of the Mineral Rent(as % of GDP) of Nicaragua in 1994 to that in 1996?
Give a very brief answer. 1.2. What is the ratio of the Mineral Rent(as % of GDP) of Jamaica in 1994 to that in 1997?
Offer a terse response. 2.05. What is the ratio of the Mineral Rent(as % of GDP) in Japan in 1994 to that in 1997?
Provide a succinct answer. 10.94. What is the ratio of the Mineral Rent(as % of GDP) of Mexico in 1994 to that in 1997?
Ensure brevity in your answer.  0.61. What is the ratio of the Mineral Rent(as % of GDP) in Nicaragua in 1994 to that in 1997?
Ensure brevity in your answer.  8.4. What is the ratio of the Mineral Rent(as % of GDP) of Jamaica in 1994 to that in 2002?
Your answer should be very brief. 3.27. What is the ratio of the Mineral Rent(as % of GDP) of Japan in 1994 to that in 2002?
Offer a terse response. 3.39. What is the ratio of the Mineral Rent(as % of GDP) of Mexico in 1994 to that in 2002?
Your response must be concise. 2.51. What is the ratio of the Mineral Rent(as % of GDP) in Nicaragua in 1994 to that in 2002?
Provide a short and direct response. 1.14. What is the ratio of the Mineral Rent(as % of GDP) of Jamaica in 1995 to that in 1996?
Your response must be concise. 0.82. What is the ratio of the Mineral Rent(as % of GDP) of Japan in 1995 to that in 1996?
Your answer should be compact. 0.83. What is the ratio of the Mineral Rent(as % of GDP) of Mexico in 1995 to that in 1996?
Your answer should be very brief. 1.55. What is the ratio of the Mineral Rent(as % of GDP) of Nicaragua in 1995 to that in 1996?
Give a very brief answer. 0.7. What is the ratio of the Mineral Rent(as % of GDP) in Jamaica in 1995 to that in 1997?
Keep it short and to the point. 1.02. What is the ratio of the Mineral Rent(as % of GDP) of Japan in 1995 to that in 1997?
Make the answer very short. 5.25. What is the ratio of the Mineral Rent(as % of GDP) of Mexico in 1995 to that in 1997?
Give a very brief answer. 1.36. What is the ratio of the Mineral Rent(as % of GDP) of Nicaragua in 1995 to that in 1997?
Provide a short and direct response. 4.9. What is the ratio of the Mineral Rent(as % of GDP) in Jamaica in 1995 to that in 2002?
Make the answer very short. 1.64. What is the ratio of the Mineral Rent(as % of GDP) of Japan in 1995 to that in 2002?
Your response must be concise. 1.63. What is the ratio of the Mineral Rent(as % of GDP) of Mexico in 1995 to that in 2002?
Your response must be concise. 5.66. What is the ratio of the Mineral Rent(as % of GDP) of Nicaragua in 1995 to that in 2002?
Offer a very short reply. 0.67. What is the ratio of the Mineral Rent(as % of GDP) of Jamaica in 1996 to that in 1997?
Offer a terse response. 1.25. What is the ratio of the Mineral Rent(as % of GDP) in Japan in 1996 to that in 1997?
Your answer should be very brief. 6.35. What is the ratio of the Mineral Rent(as % of GDP) of Mexico in 1996 to that in 1997?
Provide a short and direct response. 0.88. What is the ratio of the Mineral Rent(as % of GDP) of Nicaragua in 1996 to that in 1997?
Your answer should be very brief. 6.98. What is the ratio of the Mineral Rent(as % of GDP) in Jamaica in 1996 to that in 2002?
Your answer should be compact. 2. What is the ratio of the Mineral Rent(as % of GDP) in Japan in 1996 to that in 2002?
Make the answer very short. 1.97. What is the ratio of the Mineral Rent(as % of GDP) of Mexico in 1996 to that in 2002?
Ensure brevity in your answer.  3.66. What is the ratio of the Mineral Rent(as % of GDP) of Nicaragua in 1996 to that in 2002?
Keep it short and to the point. 0.95. What is the ratio of the Mineral Rent(as % of GDP) of Jamaica in 1997 to that in 2002?
Your answer should be compact. 1.6. What is the ratio of the Mineral Rent(as % of GDP) in Japan in 1997 to that in 2002?
Make the answer very short. 0.31. What is the ratio of the Mineral Rent(as % of GDP) in Mexico in 1997 to that in 2002?
Give a very brief answer. 4.15. What is the ratio of the Mineral Rent(as % of GDP) in Nicaragua in 1997 to that in 2002?
Give a very brief answer. 0.14. What is the difference between the highest and the second highest Mineral Rent(as % of GDP) in Jamaica?
Your answer should be very brief. 3.59. What is the difference between the highest and the second highest Mineral Rent(as % of GDP) in Japan?
Your answer should be very brief. 0. What is the difference between the highest and the second highest Mineral Rent(as % of GDP) in Mexico?
Ensure brevity in your answer.  0.05. What is the difference between the highest and the second highest Mineral Rent(as % of GDP) in Nicaragua?
Keep it short and to the point. 0.01. What is the difference between the highest and the lowest Mineral Rent(as % of GDP) of Jamaica?
Your answer should be compact. 6.9. What is the difference between the highest and the lowest Mineral Rent(as % of GDP) of Mexico?
Offer a terse response. 0.16. What is the difference between the highest and the lowest Mineral Rent(as % of GDP) in Nicaragua?
Your answer should be compact. 0.06. 